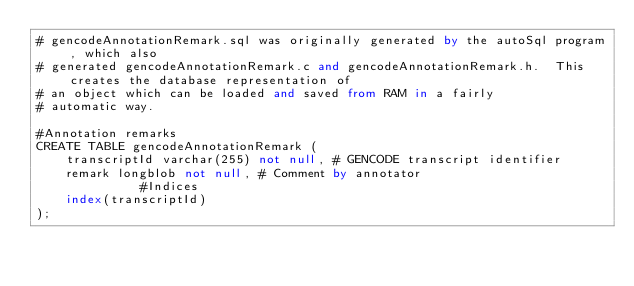Convert code to text. <code><loc_0><loc_0><loc_500><loc_500><_SQL_># gencodeAnnotationRemark.sql was originally generated by the autoSql program, which also 
# generated gencodeAnnotationRemark.c and gencodeAnnotationRemark.h.  This creates the database representation of
# an object which can be loaded and saved from RAM in a fairly 
# automatic way.

#Annotation remarks
CREATE TABLE gencodeAnnotationRemark (
    transcriptId varchar(255) not null,	# GENCODE transcript identifier
    remark longblob not null,	# Comment by annotator
              #Indices
    index(transcriptId)
);
</code> 